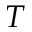<formula> <loc_0><loc_0><loc_500><loc_500>T</formula> 